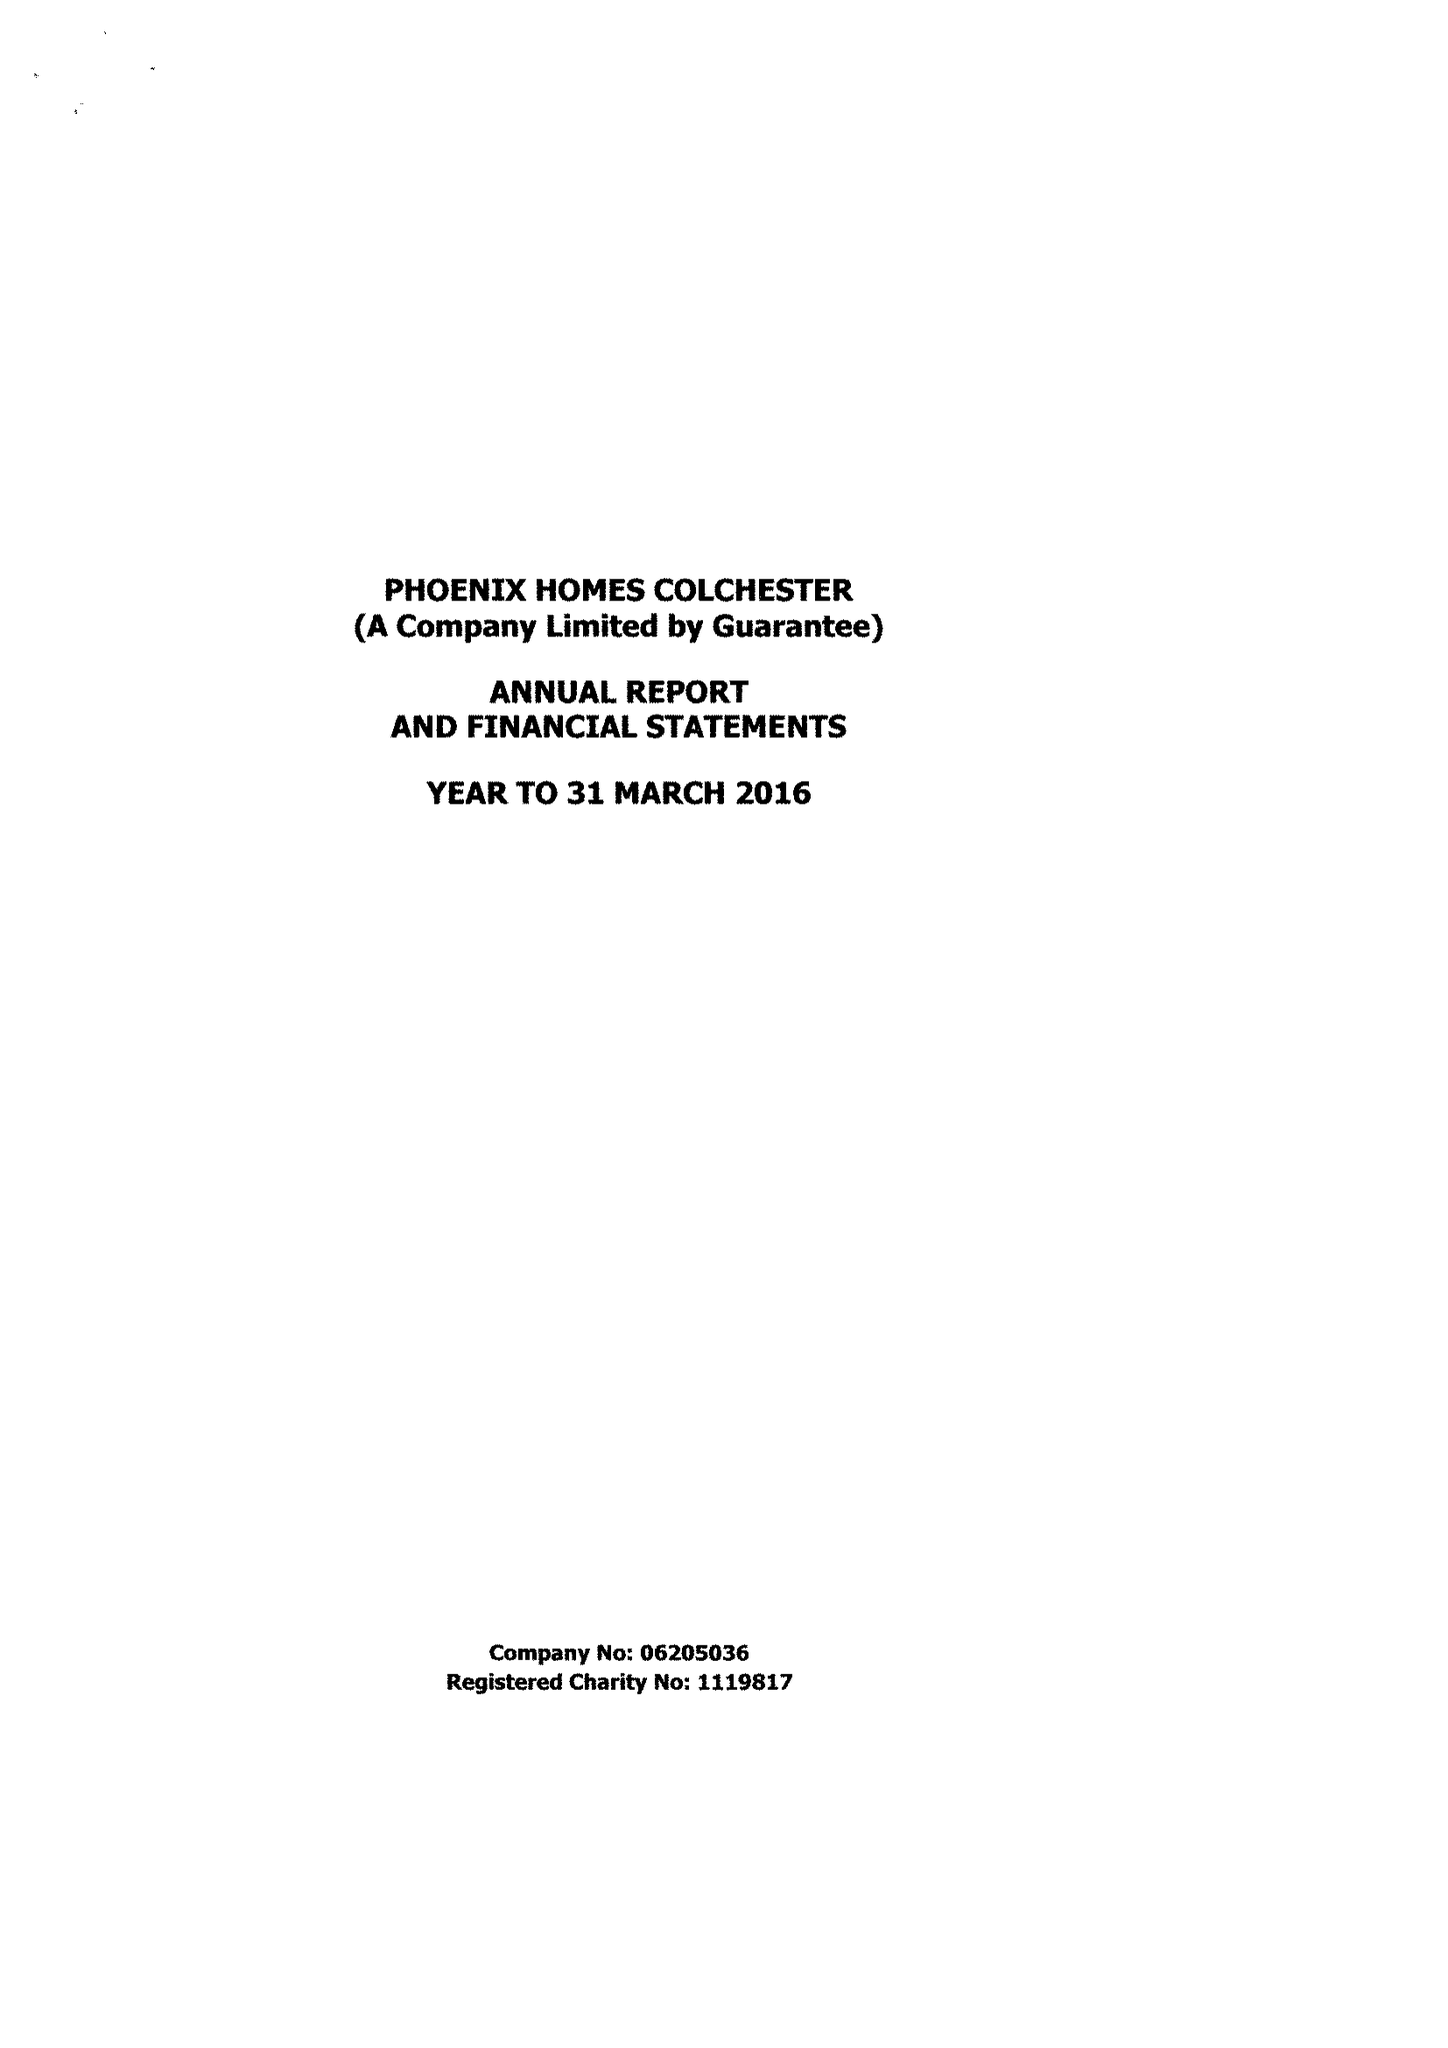What is the value for the report_date?
Answer the question using a single word or phrase. 2016-03-31 